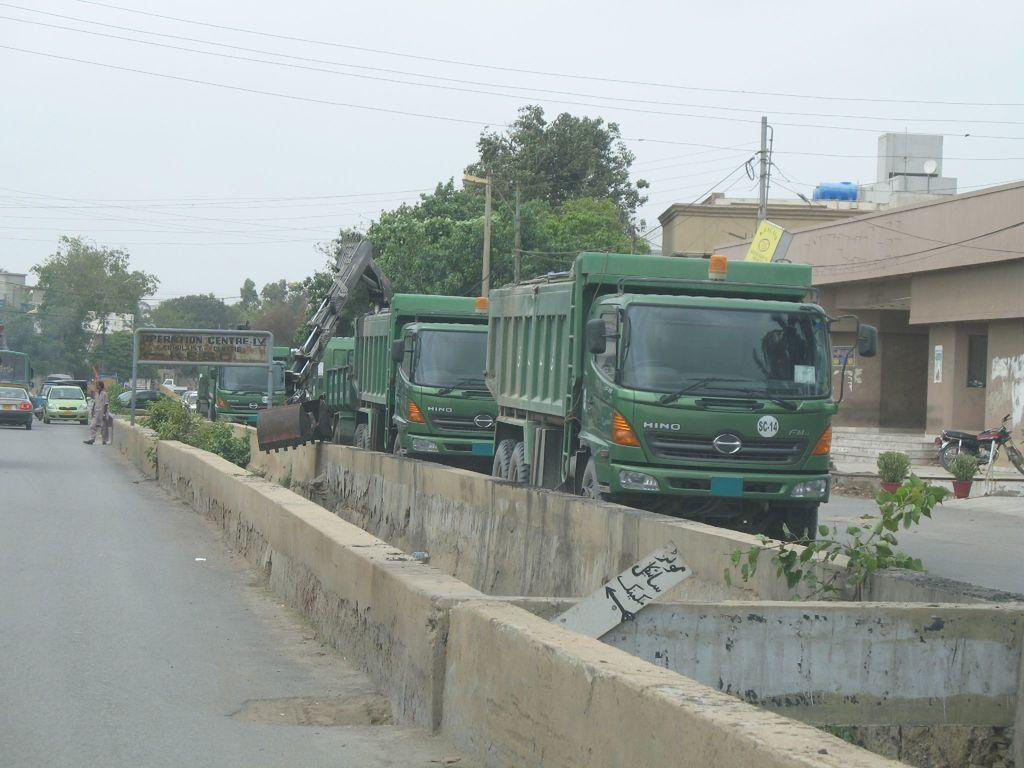What can be seen on the road in the image? There are vehicles on the road in the image. What type of structures are present in the image? There are buildings in the image. What are the poles used for in the image? The poles are likely used for supporting cables in the image. What else can be seen in the image besides vehicles and buildings? There are trees in the image. What is visible in the background of the image? The sky is visible in the background of the image. What type of ornament is hanging from the trees in the image? There are no ornaments hanging from the trees in the image; only trees, vehicles, buildings, poles, cables, and the sky are present. What is the needle used for in the image? There is no needle present in the image. 